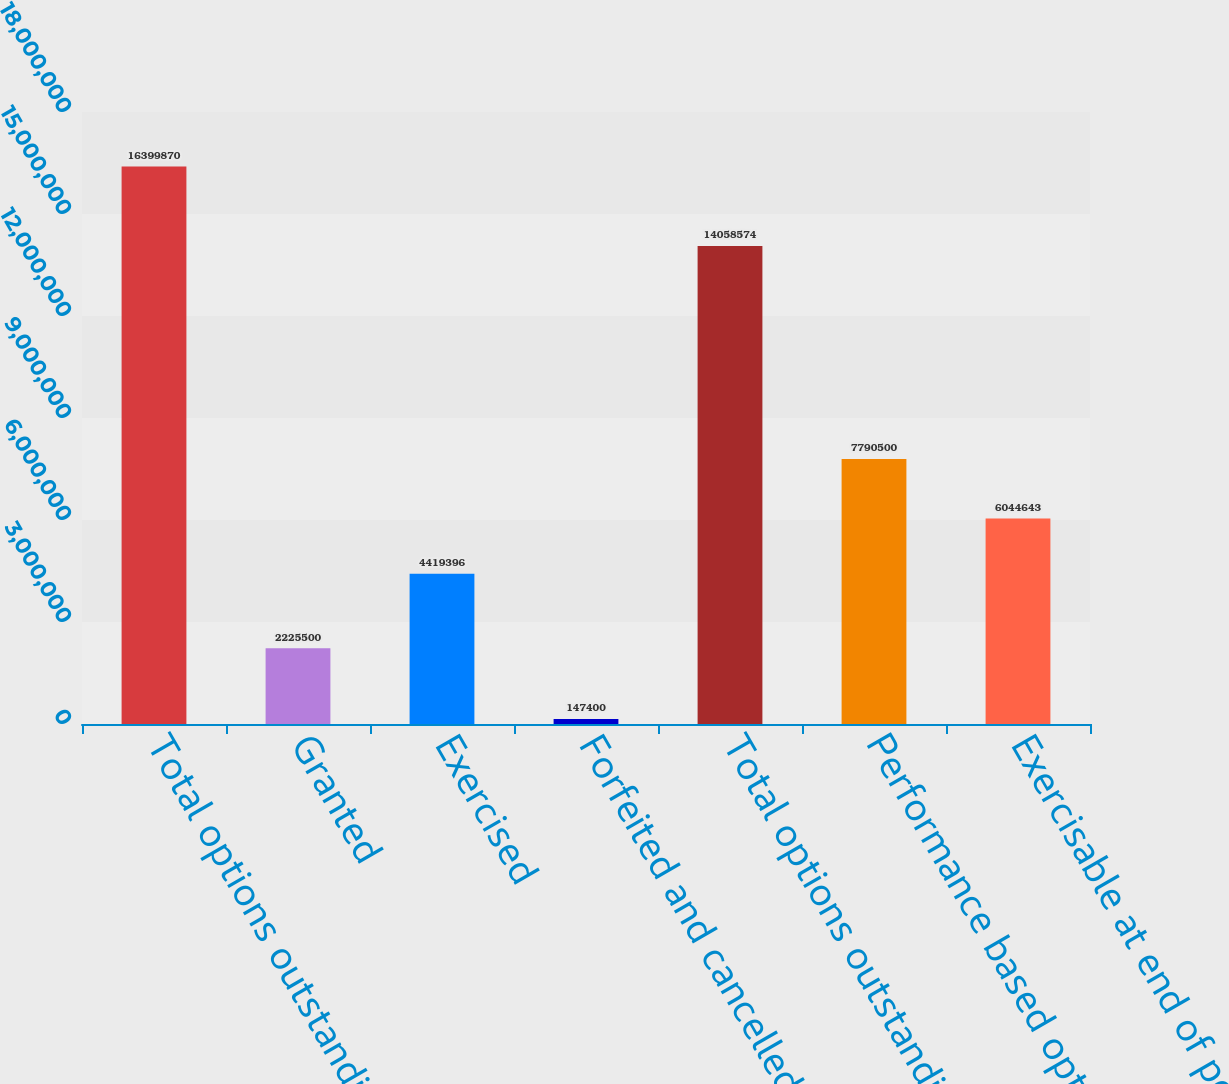Convert chart to OTSL. <chart><loc_0><loc_0><loc_500><loc_500><bar_chart><fcel>Total options outstanding<fcel>Granted<fcel>Exercised<fcel>Forfeited and cancelled<fcel>Total options outstanding end<fcel>Performance based options<fcel>Exercisable at end of period<nl><fcel>1.63999e+07<fcel>2.2255e+06<fcel>4.4194e+06<fcel>147400<fcel>1.40586e+07<fcel>7.7905e+06<fcel>6.04464e+06<nl></chart> 